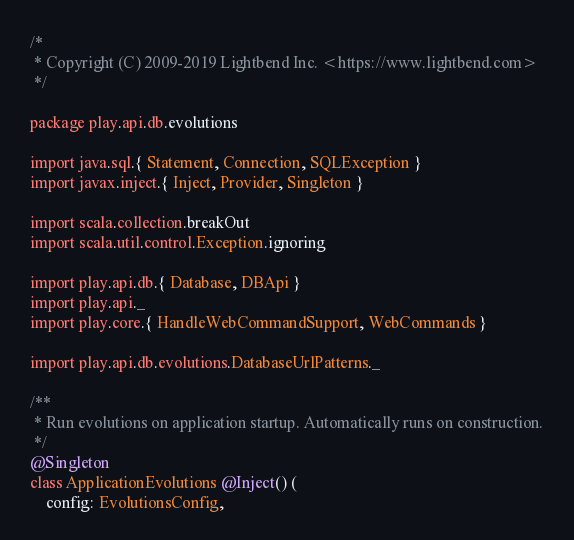<code> <loc_0><loc_0><loc_500><loc_500><_Scala_>/*
 * Copyright (C) 2009-2019 Lightbend Inc. <https://www.lightbend.com>
 */

package play.api.db.evolutions

import java.sql.{ Statement, Connection, SQLException }
import javax.inject.{ Inject, Provider, Singleton }

import scala.collection.breakOut
import scala.util.control.Exception.ignoring

import play.api.db.{ Database, DBApi }
import play.api._
import play.core.{ HandleWebCommandSupport, WebCommands }

import play.api.db.evolutions.DatabaseUrlPatterns._

/**
 * Run evolutions on application startup. Automatically runs on construction.
 */
@Singleton
class ApplicationEvolutions @Inject() (
    config: EvolutionsConfig,</code> 